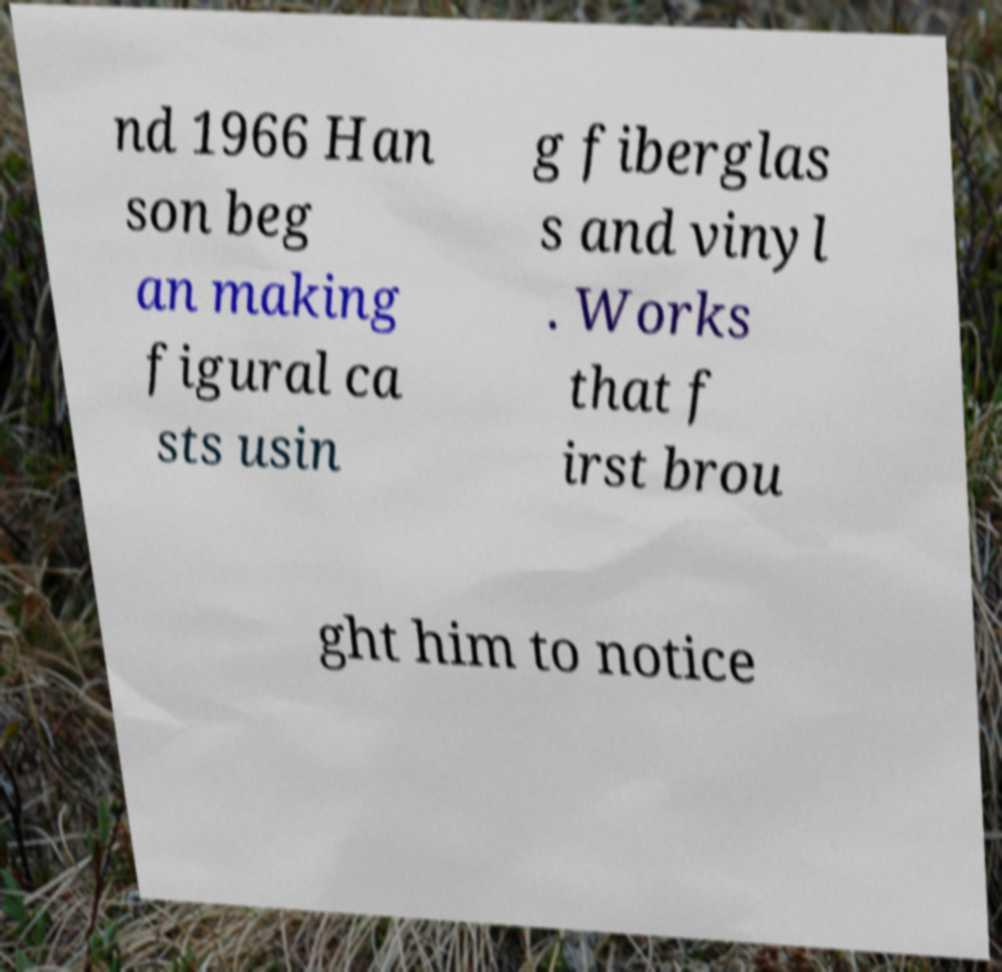Please identify and transcribe the text found in this image. nd 1966 Han son beg an making figural ca sts usin g fiberglas s and vinyl . Works that f irst brou ght him to notice 